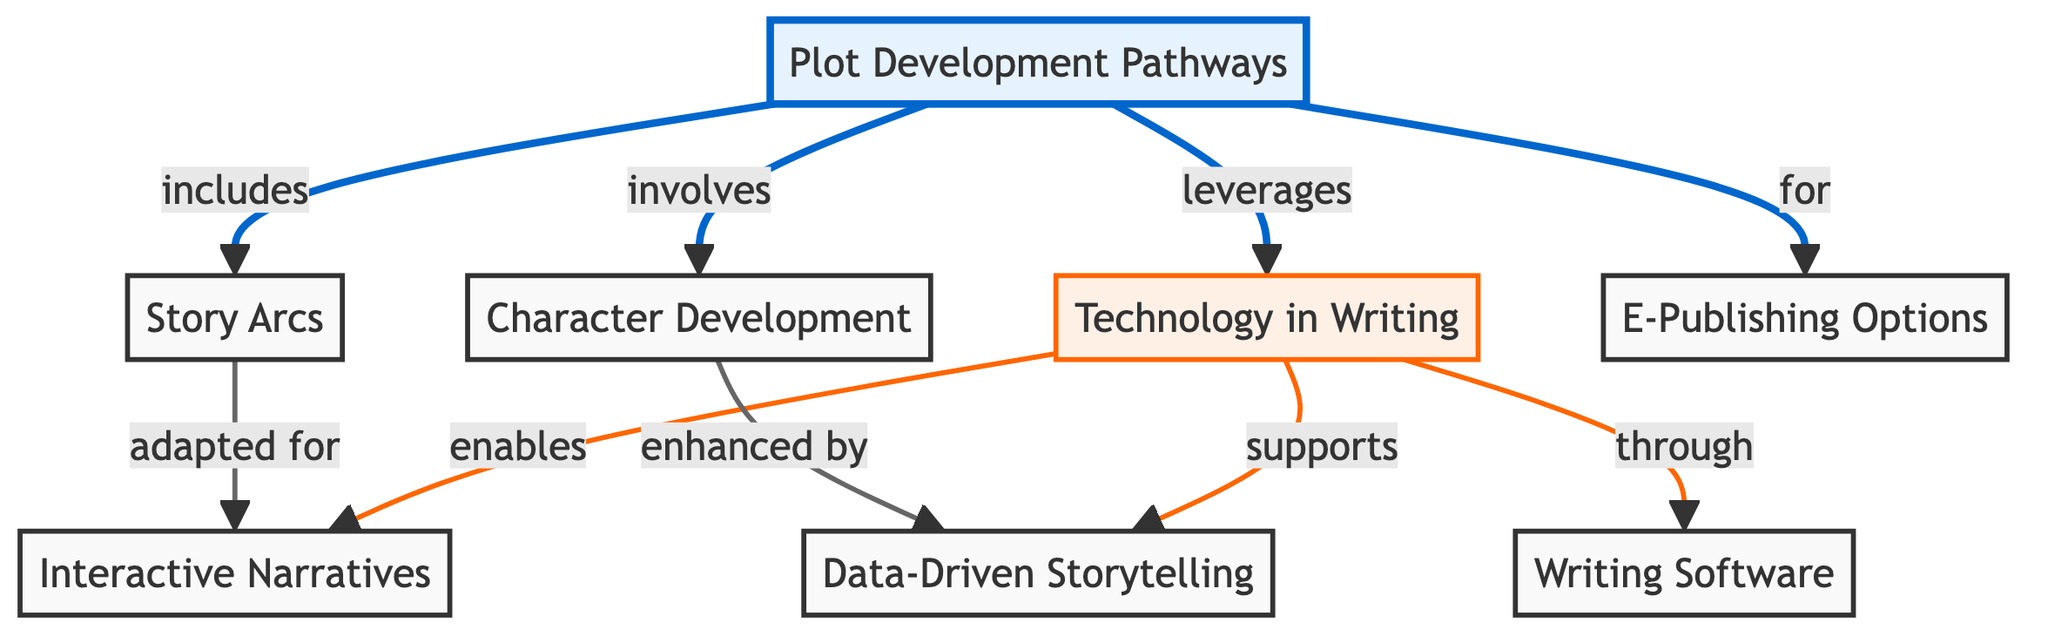What is the total number of nodes in the diagram? The diagram lists the following nodes: Plot Development Pathways, Story Arcs, Character Development, Technology in Writing, Interactive Narratives, E-Publishing Options, Writing Software, and Data-Driven Storytelling. Counting these, there are 8 nodes total.
Answer: 8 Which node is linked to E-Publishing Options? E-Publishing Options is linked to the main node, Plot Development Pathways, as indicated by the edge labeled "for". There are no other direct links shown to E-Publishing Options from any other nodes.
Answer: Plot Development Pathways What relationship connects Story Arcs and Interactive Narratives? The relationship between Story Arcs and Interactive Narratives is described by the edge labeled "adapted for". This means that Interactive Narratives are a variant of something that arises from Story Arcs.
Answer: adapted for How does Technology in Writing support Data-Driven Storytelling? Technology in Writing supports Data-Driven Storytelling through an edge labeled "supports". This indicates that advancements in technology contribute positively to the effectiveness of Data-Driven Storytelling.
Answer: supports Which node is involved in Character Development? Character Development is involved in Plot Development Pathways, as represented by the edge labeled "involves". This shows that Character Development is a component within the broader context of Plot Development Pathways.
Answer: Plot Development Pathways What is the connection between Technology in Writing and Writing Software? The connection between Technology in Writing and Writing Software is established by the edge labeled "through". This denotes that Writing Software is a medium or method utilized within the framework of Technology in Writing.
Answer: through What role does Technology in Writing play in Interactive Narratives? Technology in Writing enables Interactive Narratives, as signified by the edge labeled "enables". This indicates that without Technology in Writing, the creation of Interactive Narratives would not be possible.
Answer: enables What kind of storytelling is enhanced by Character Development? Data-Driven Storytelling is enhanced by Character Development, indicated by the edge labeled "enhanced by". This means that when characters are well-developed, it improves the quality or impact of Data-Driven Storytelling.
Answer: enhanced by 